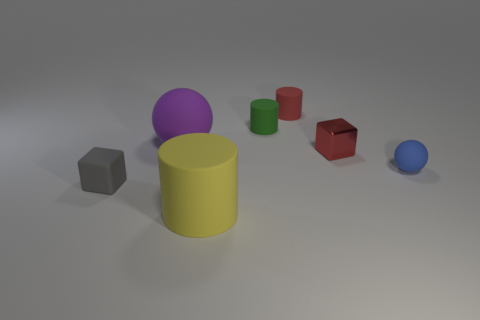Add 1 purple rubber things. How many objects exist? 8 Subtract all cubes. How many objects are left? 5 Add 6 tiny rubber cylinders. How many tiny rubber cylinders exist? 8 Subtract 0 purple cylinders. How many objects are left? 7 Subtract all large yellow matte blocks. Subtract all tiny red blocks. How many objects are left? 6 Add 6 rubber cubes. How many rubber cubes are left? 7 